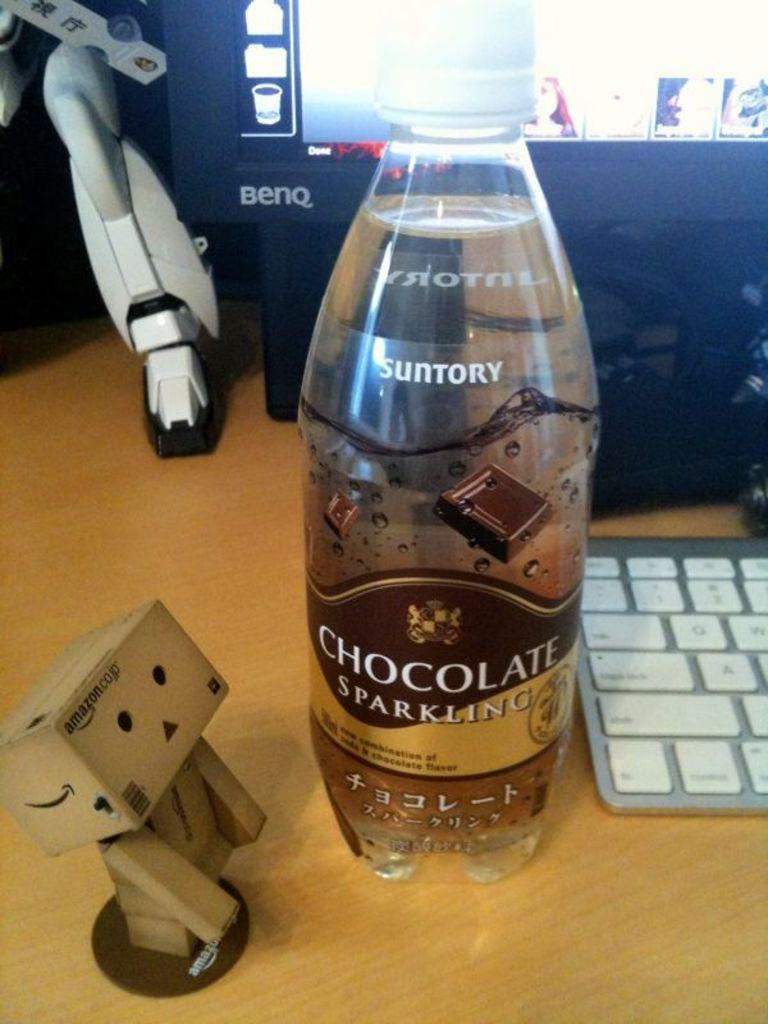<image>
Share a concise interpretation of the image provided. A bottle of chocolate sparkling water is on a desk in front of a computer. 